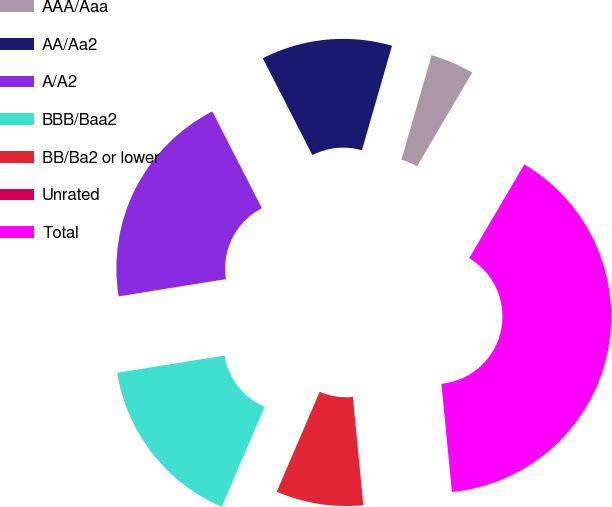Convert chart to OTSL. <chart><loc_0><loc_0><loc_500><loc_500><pie_chart><fcel>AAA/Aaa<fcel>AA/Aa2<fcel>A/A2<fcel>BBB/Baa2<fcel>BB/Ba2 or lower<fcel>Unrated<fcel>Total<nl><fcel>4.0%<fcel>12.0%<fcel>20.0%<fcel>16.0%<fcel>8.0%<fcel>0.0%<fcel>39.99%<nl></chart> 